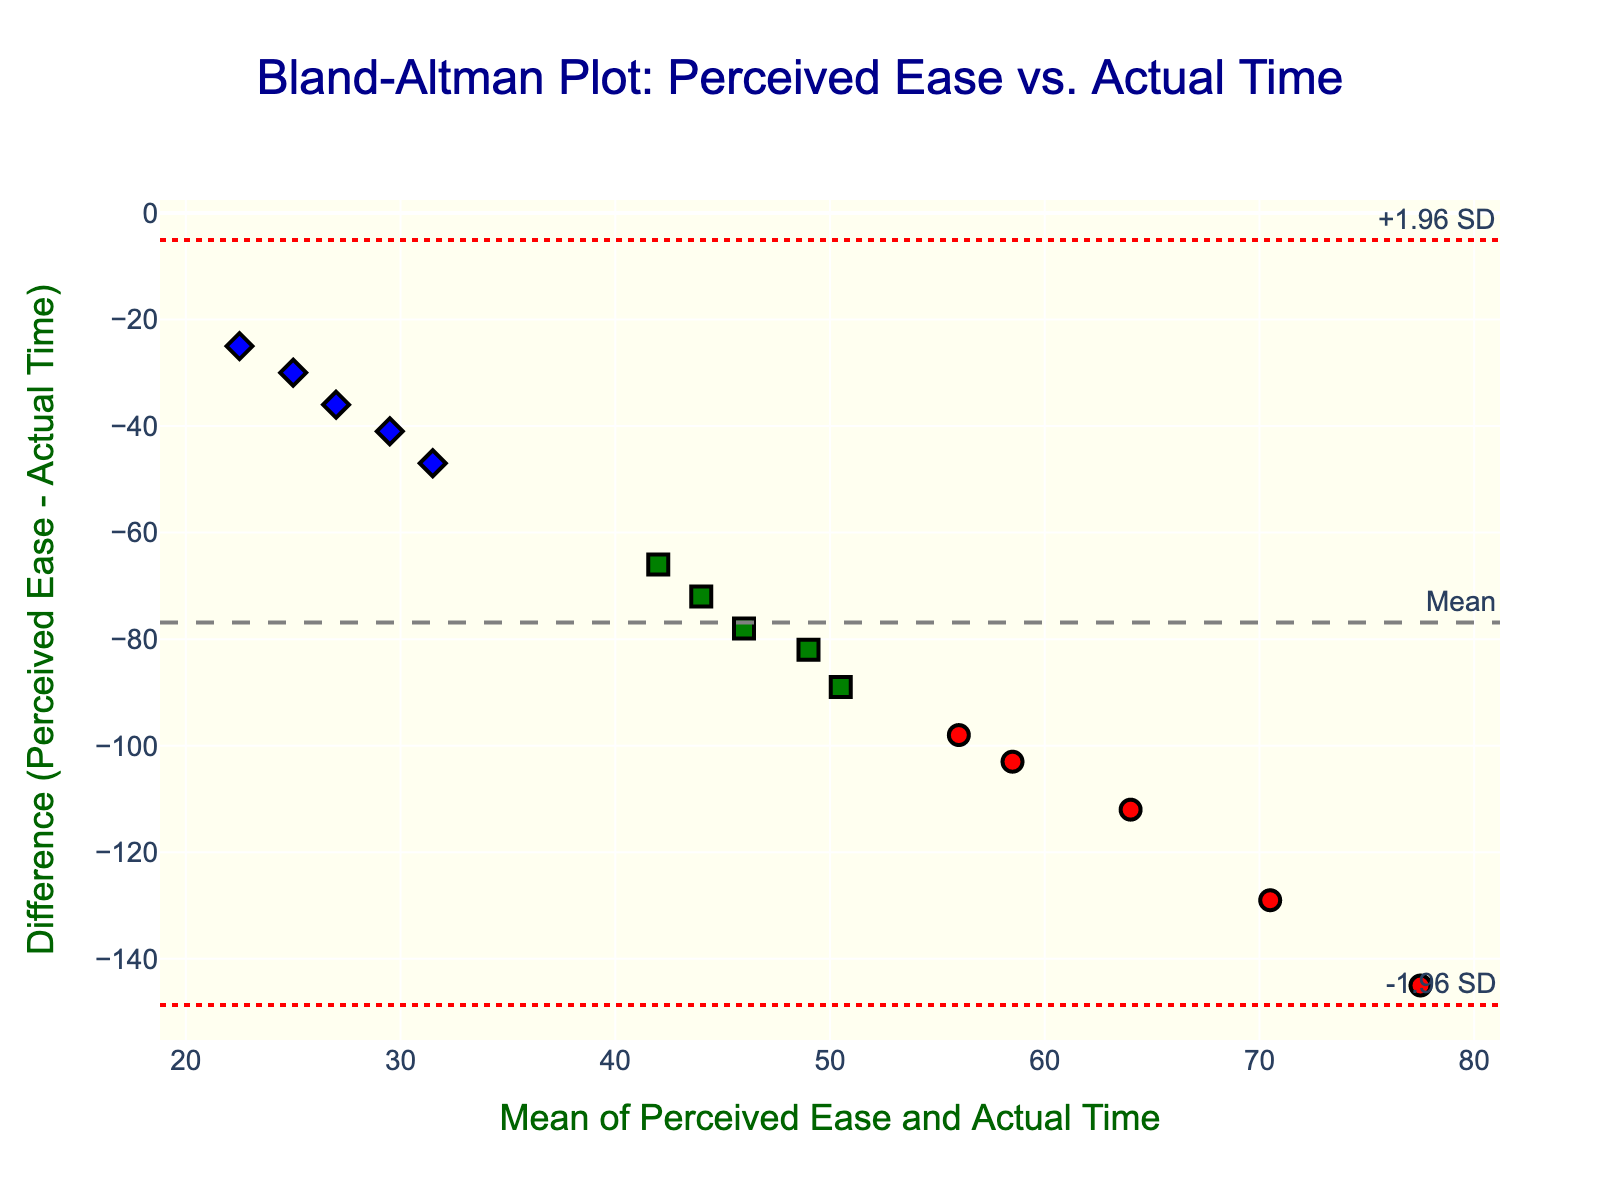What's the title of the figure? The title of the figure is usually displayed at the top, centered. In this case, it reads: "Bland-Altman Plot: Perceived Ease vs. Actual Time"
Answer: Bland-Altman Plot: Perceived Ease vs. Actual Time What does the y-axis represent? The y-axis of a Bland-Altman plot typically shows the difference between two measurements. Here, it represents "Difference (Perceived Ease - Actual Time)"
Answer: Difference (Perceived Ease - Actual Time) How many total data points are plotted? Counting the individual markers on the plot will give the total number of data points. There are 15 users, hence 15 data points.
Answer: 15 Which experience level has the highest perceived ease of use? By hovering over the points or observing the legend and colors, "Expert" users have the highest perceived ease, visible from points near the high end of the "perceived_ease" axis (around 10).
Answer: Expert What color represents the "Intermediate" experience level? The figure's color legend shows that "Intermediate" experience level data points are green.
Answer: Green What's the mean line value on the y-axis? The mean of the differences is represented by the dashed line on the y-axis, labeled "Mean." It falls at approximately -85.
Answer: -85 What is the value of the upper limit of agreement (+1.96 SD)? The upper limit is shown by the dot-dashed red line on the y-axis, around -35, indicated by the "+1.96 SD" annotation.
Answer: -35 What is the difference (perceived ease - actual time) for user 10, a novice? Locate the point representing novice users (red circle). For user 10, perceived ease is 5 and actual time is 150, so the difference is 5 - 150 = -145.
Answer: -145 Are there any "Expert" users with differences outside the limits of agreement? Observing the blue diamond markers (Experts), see if any fall outside the red dot-dashed lines (+/-1.96 SD). None do, indicating all are within the limits.
Answer: No Which experience level shows the most variability in the difference? Examine the spread of each experience level's points on the y-axis. "Novice" points (red circles) have the widest spread, indicating the most variability.
Answer: Novice 